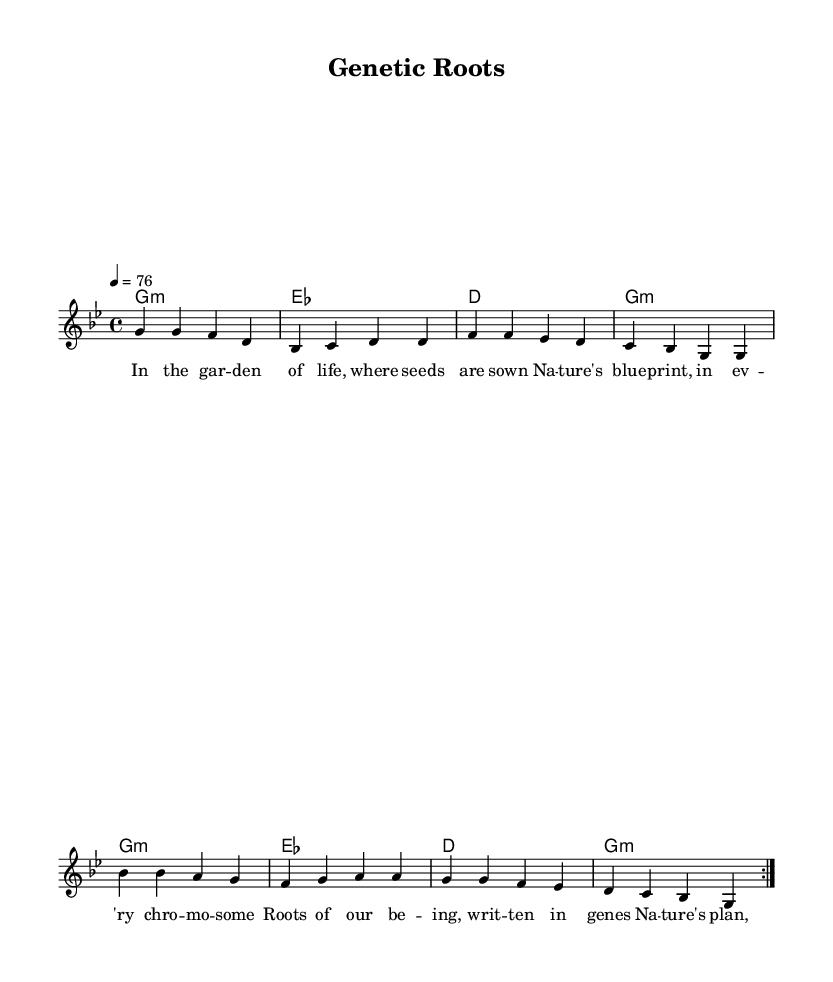What is the key signature of this music? The key signature is G minor, which contains two flats (B flat and E flat). The key is indicated by the 'g' in the global settings.
Answer: G minor What is the time signature of this piece? The time signature shown in the global settings is 4/4, meaning there are four beats in each measure. This is confirmed by the notation appearing in the score.
Answer: 4/4 What is the tempo marking? The tempo marking indicates a speed of quarter note equals 76 beats per minute, which can be found in the global section of the score.
Answer: 76 How many times is the melody repeated? The melody is indicated to be repeated twice, as denoted by 'repeat volta 2' in the melody section. This tells performers to play the sections indicated two times before moving on.
Answer: 2 What is the primary lyrical theme reflected in the piece? The lyrics focus on the concepts of nature and genetics, clearly expressed in phrases related to the garden of life and genes in every chromosome, suggesting a metaphorical examination of nature versus nurture.
Answer: Nature vs. nurture What type of chords are primarily used in this piece? The chords used in the score are mostly minor chords, indicated by 'm', specifically G minor and E flat, which is a characteristic feature of Reggae music.
Answer: Minor What does the phrase 'roots of our being' metaphorically refer to in the lyrics? This phrase metaphorically points to genetics and ancestry, suggesting that our fundamental characteristics are deeply embedded in our genetic makeup, aligning with the theme of nature's essence.
Answer: Genetics 